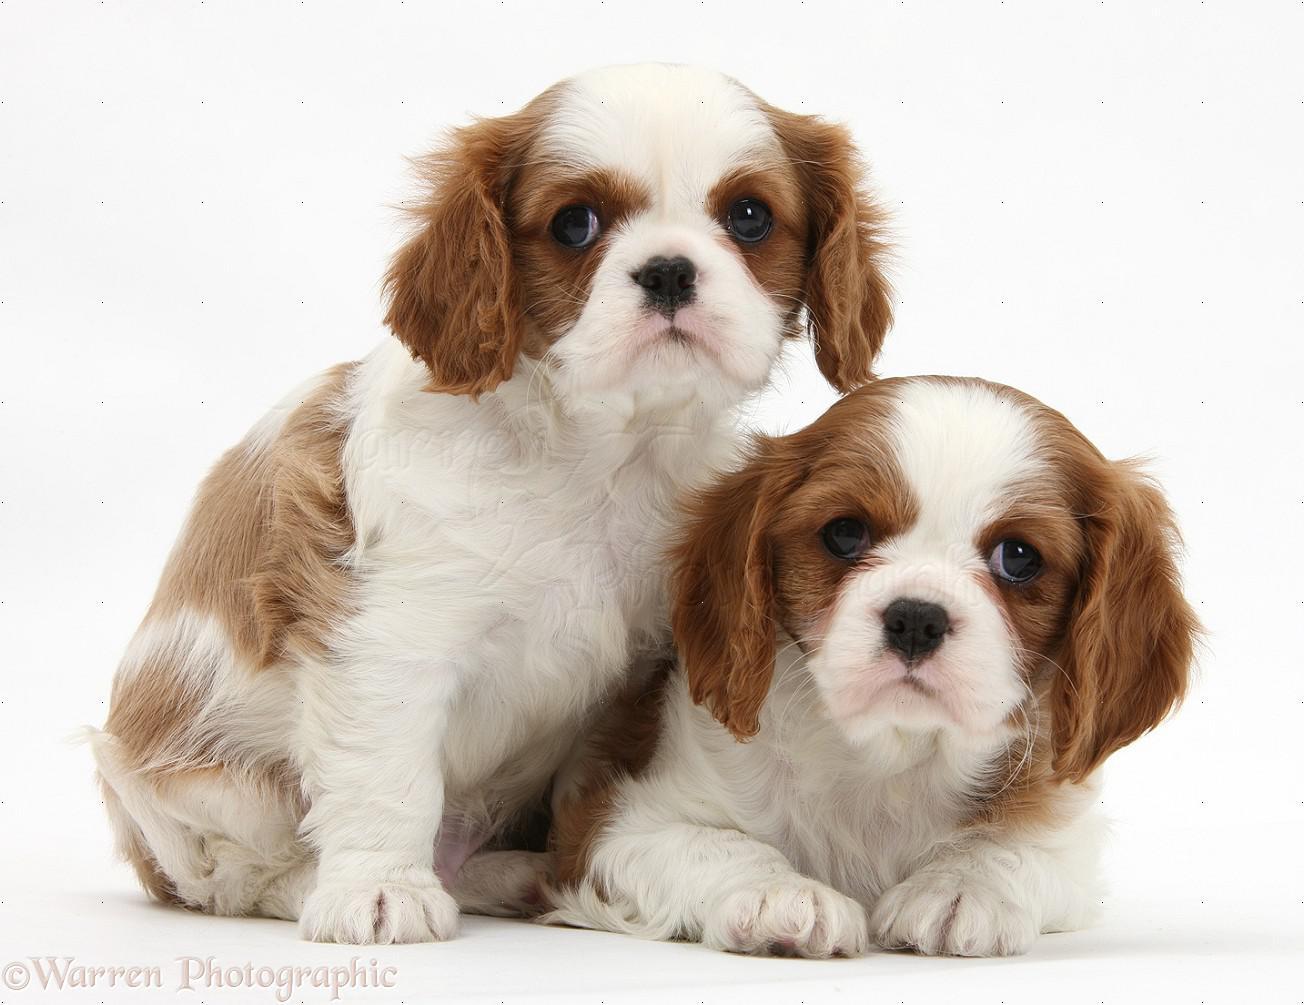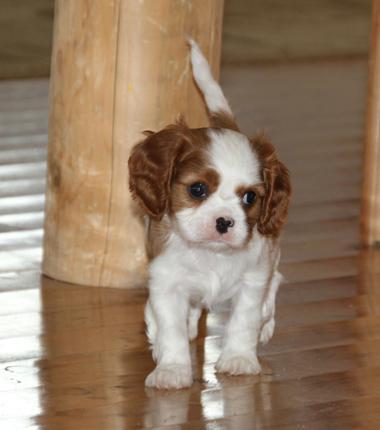The first image is the image on the left, the second image is the image on the right. For the images shown, is this caption "There are no more than three animals" true? Answer yes or no. Yes. 